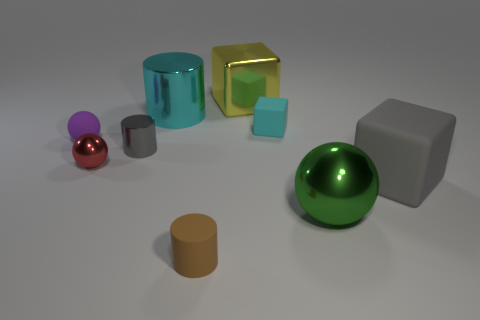There is a big cube to the left of the rubber cube in front of the purple thing; are there any green balls left of it?
Your answer should be very brief. No. How many other objects are the same color as the small metal cylinder?
Offer a terse response. 1. What number of tiny objects are to the right of the brown cylinder and in front of the gray metal thing?
Provide a short and direct response. 0. The large yellow object has what shape?
Keep it short and to the point. Cube. What number of other objects are there of the same material as the large yellow block?
Provide a short and direct response. 4. There is a shiny cylinder behind the small thing that is right of the cylinder that is right of the large cyan shiny cylinder; what is its color?
Ensure brevity in your answer.  Cyan. There is a purple sphere that is the same size as the cyan matte cube; what is its material?
Make the answer very short. Rubber. What number of things are big metallic objects in front of the purple rubber sphere or gray objects?
Make the answer very short. 3. Are there any small blue rubber cylinders?
Keep it short and to the point. No. There is a sphere that is right of the brown cylinder; what is it made of?
Offer a terse response. Metal. 